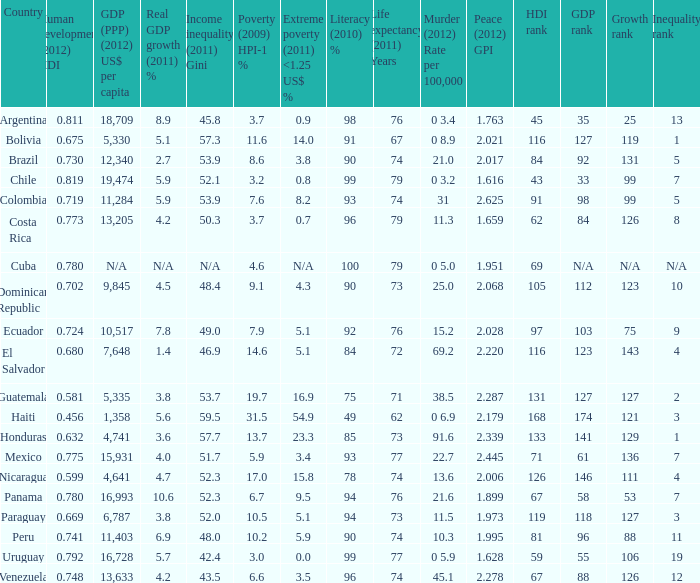What is the sum of poverty (2009) HPI-1 % when the GDP (PPP) (2012) US$ per capita of 11,284? 1.0. 